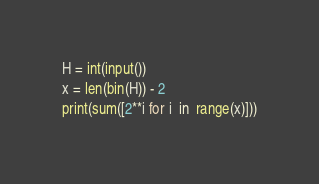Convert code to text. <code><loc_0><loc_0><loc_500><loc_500><_Python_>H = int(input())
x = len(bin(H)) - 2
print(sum([2**i for i  in  range(x)]))</code> 